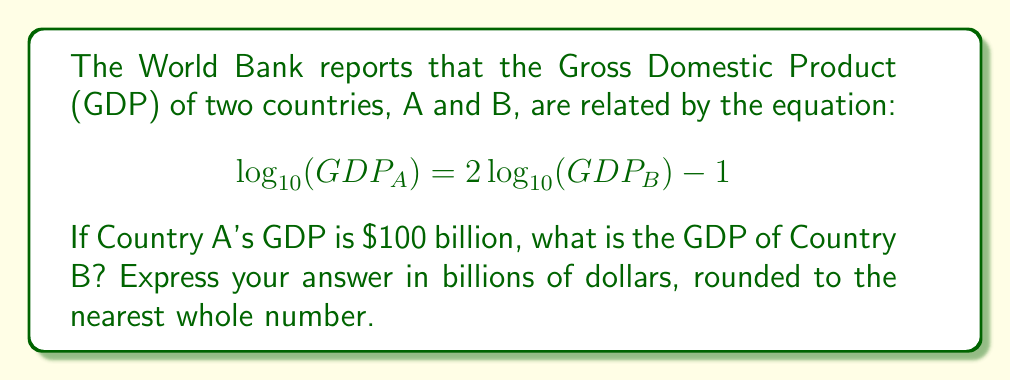Teach me how to tackle this problem. Let's solve this step-by-step:

1) We're given that $GDP_A = 100$ billion. Let's substitute this into the equation:

   $$\log_{10}(100) = 2\log_{10}(GDP_B) - 1$$

2) Simplify the left side:
   
   $$2 = 2\log_{10}(GDP_B) - 1$$

3) Add 1 to both sides:

   $$3 = 2\log_{10}(GDP_B)$$

4) Divide both sides by 2:

   $$\frac{3}{2} = \log_{10}(GDP_B)$$

5) To solve for $GDP_B$, we need to apply the inverse function (exponential) to both sides:

   $$10^{\frac{3}{2}} = GDP_B$$

6) Calculate:

   $$GDP_B = 10^{1.5} \approx 31.62$$

7) Rounding to the nearest whole number:

   $$GDP_B \approx 32$$

Therefore, the GDP of Country B is approximately 32 billion dollars.
Answer: $32 billion 